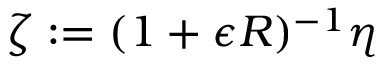<formula> <loc_0><loc_0><loc_500><loc_500>\zeta \colon = ( 1 + \epsilon R ) ^ { - 1 } \eta</formula> 